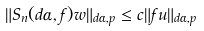<formula> <loc_0><loc_0><loc_500><loc_500>\| S _ { n } ( d \alpha , f ) w \| _ { d \alpha , p } \leq c \| f u \| _ { d \alpha , p }</formula> 